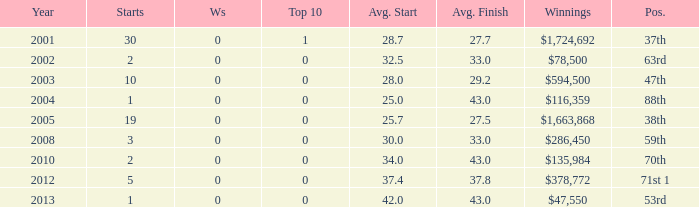How many starts for an average finish greater than 43? None. 